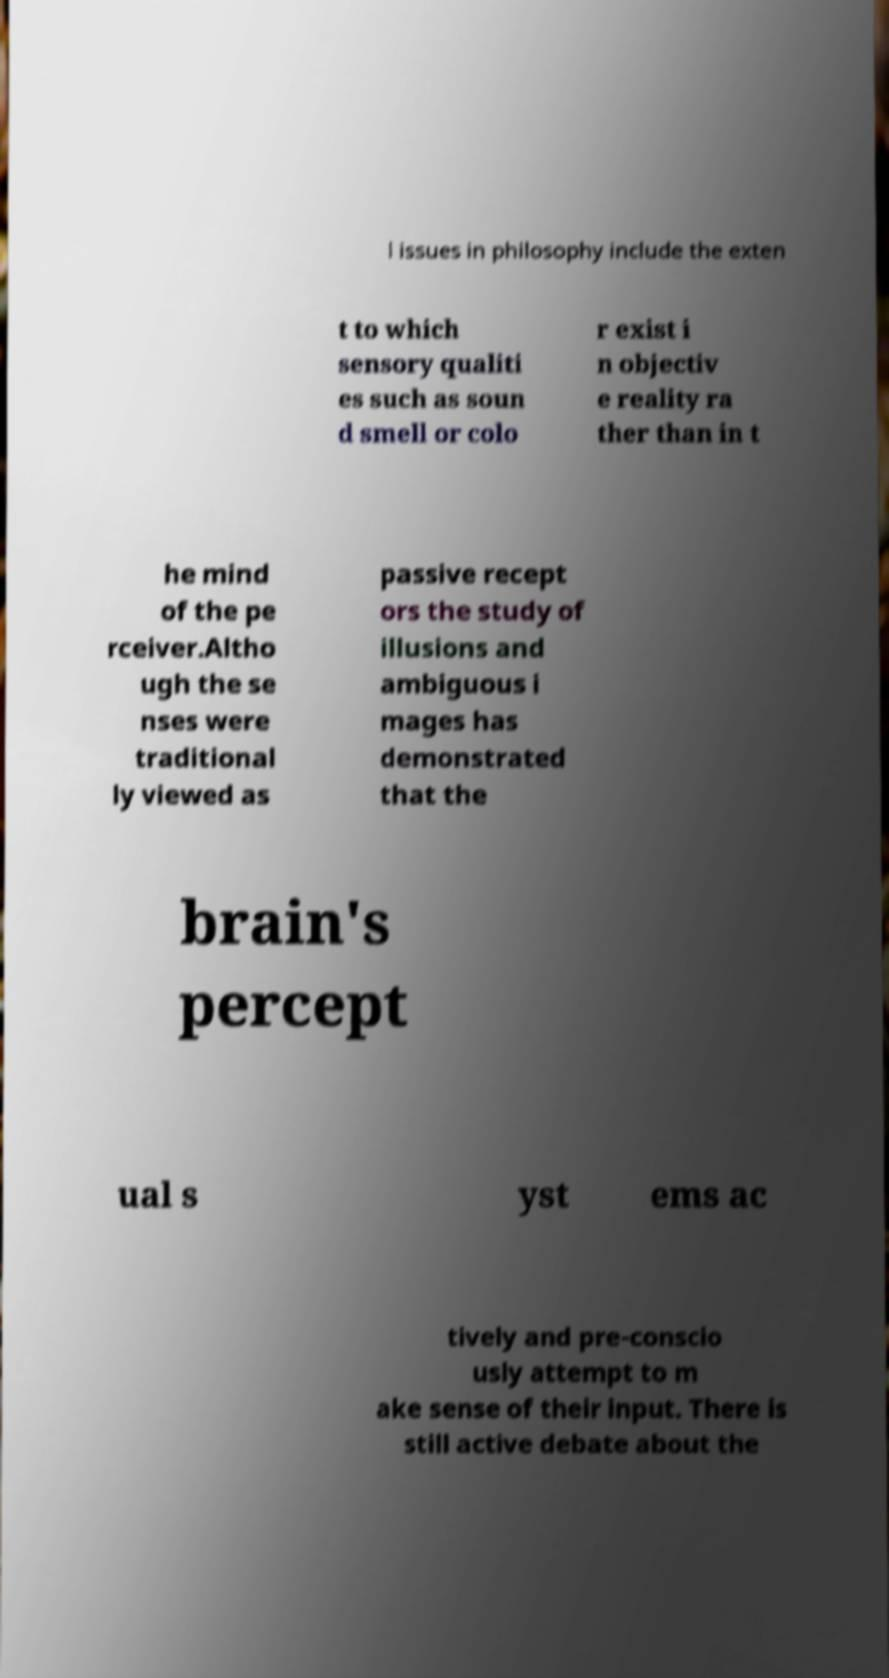There's text embedded in this image that I need extracted. Can you transcribe it verbatim? l issues in philosophy include the exten t to which sensory qualiti es such as soun d smell or colo r exist i n objectiv e reality ra ther than in t he mind of the pe rceiver.Altho ugh the se nses were traditional ly viewed as passive recept ors the study of illusions and ambiguous i mages has demonstrated that the brain's percept ual s yst ems ac tively and pre-conscio usly attempt to m ake sense of their input. There is still active debate about the 